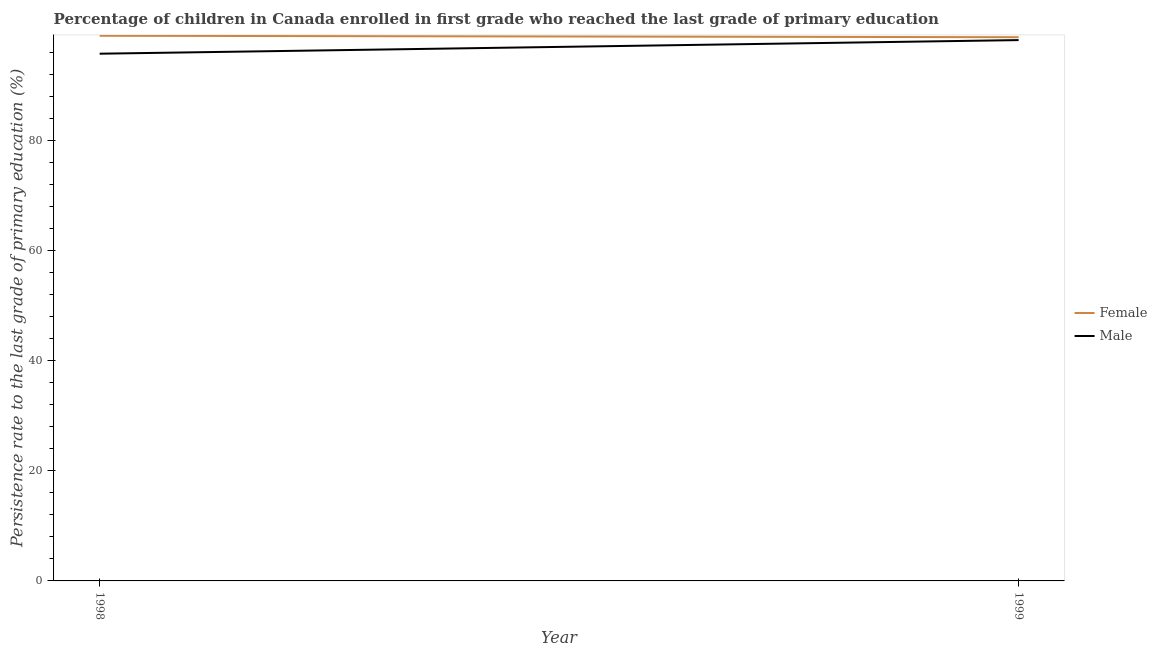How many different coloured lines are there?
Offer a very short reply. 2. What is the persistence rate of male students in 1999?
Provide a short and direct response. 98.34. Across all years, what is the maximum persistence rate of male students?
Offer a very short reply. 98.34. Across all years, what is the minimum persistence rate of female students?
Offer a very short reply. 98.87. In which year was the persistence rate of male students maximum?
Keep it short and to the point. 1999. In which year was the persistence rate of male students minimum?
Give a very brief answer. 1998. What is the total persistence rate of male students in the graph?
Offer a very short reply. 194.21. What is the difference between the persistence rate of female students in 1998 and that in 1999?
Your answer should be very brief. 0.26. What is the difference between the persistence rate of female students in 1998 and the persistence rate of male students in 1999?
Give a very brief answer. 0.79. What is the average persistence rate of female students per year?
Provide a succinct answer. 99. In the year 1998, what is the difference between the persistence rate of male students and persistence rate of female students?
Your answer should be very brief. -3.26. In how many years, is the persistence rate of male students greater than 8 %?
Provide a succinct answer. 2. What is the ratio of the persistence rate of male students in 1998 to that in 1999?
Your answer should be compact. 0.97. Does the graph contain grids?
Offer a very short reply. No. Where does the legend appear in the graph?
Keep it short and to the point. Center right. What is the title of the graph?
Your response must be concise. Percentage of children in Canada enrolled in first grade who reached the last grade of primary education. Does "Non-resident workers" appear as one of the legend labels in the graph?
Your answer should be very brief. No. What is the label or title of the X-axis?
Give a very brief answer. Year. What is the label or title of the Y-axis?
Your response must be concise. Persistence rate to the last grade of primary education (%). What is the Persistence rate to the last grade of primary education (%) of Female in 1998?
Give a very brief answer. 99.13. What is the Persistence rate to the last grade of primary education (%) of Male in 1998?
Provide a short and direct response. 95.87. What is the Persistence rate to the last grade of primary education (%) in Female in 1999?
Provide a succinct answer. 98.87. What is the Persistence rate to the last grade of primary education (%) in Male in 1999?
Your answer should be compact. 98.34. Across all years, what is the maximum Persistence rate to the last grade of primary education (%) of Female?
Provide a succinct answer. 99.13. Across all years, what is the maximum Persistence rate to the last grade of primary education (%) in Male?
Offer a very short reply. 98.34. Across all years, what is the minimum Persistence rate to the last grade of primary education (%) of Female?
Your answer should be very brief. 98.87. Across all years, what is the minimum Persistence rate to the last grade of primary education (%) in Male?
Provide a succinct answer. 95.87. What is the total Persistence rate to the last grade of primary education (%) in Female in the graph?
Your response must be concise. 198. What is the total Persistence rate to the last grade of primary education (%) in Male in the graph?
Ensure brevity in your answer.  194.21. What is the difference between the Persistence rate to the last grade of primary education (%) of Female in 1998 and that in 1999?
Provide a short and direct response. 0.26. What is the difference between the Persistence rate to the last grade of primary education (%) of Male in 1998 and that in 1999?
Offer a very short reply. -2.47. What is the difference between the Persistence rate to the last grade of primary education (%) in Female in 1998 and the Persistence rate to the last grade of primary education (%) in Male in 1999?
Ensure brevity in your answer.  0.79. What is the average Persistence rate to the last grade of primary education (%) in Female per year?
Provide a succinct answer. 99. What is the average Persistence rate to the last grade of primary education (%) in Male per year?
Your answer should be compact. 97.11. In the year 1998, what is the difference between the Persistence rate to the last grade of primary education (%) of Female and Persistence rate to the last grade of primary education (%) of Male?
Keep it short and to the point. 3.26. In the year 1999, what is the difference between the Persistence rate to the last grade of primary education (%) in Female and Persistence rate to the last grade of primary education (%) in Male?
Offer a terse response. 0.53. What is the ratio of the Persistence rate to the last grade of primary education (%) in Female in 1998 to that in 1999?
Offer a terse response. 1. What is the ratio of the Persistence rate to the last grade of primary education (%) in Male in 1998 to that in 1999?
Provide a short and direct response. 0.97. What is the difference between the highest and the second highest Persistence rate to the last grade of primary education (%) in Female?
Ensure brevity in your answer.  0.26. What is the difference between the highest and the second highest Persistence rate to the last grade of primary education (%) in Male?
Your answer should be very brief. 2.47. What is the difference between the highest and the lowest Persistence rate to the last grade of primary education (%) in Female?
Your answer should be very brief. 0.26. What is the difference between the highest and the lowest Persistence rate to the last grade of primary education (%) of Male?
Keep it short and to the point. 2.47. 